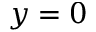Convert formula to latex. <formula><loc_0><loc_0><loc_500><loc_500>y = 0</formula> 